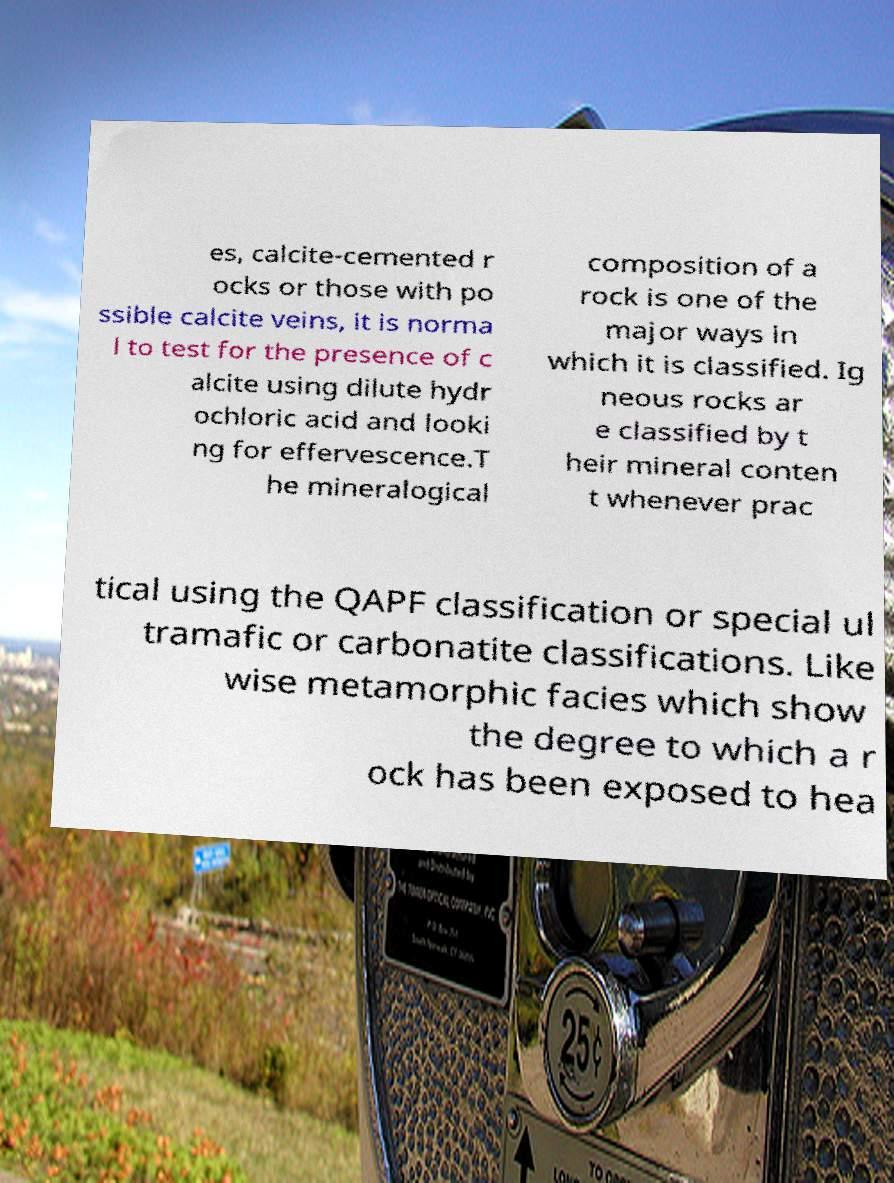What messages or text are displayed in this image? I need them in a readable, typed format. es, calcite-cemented r ocks or those with po ssible calcite veins, it is norma l to test for the presence of c alcite using dilute hydr ochloric acid and looki ng for effervescence.T he mineralogical composition of a rock is one of the major ways in which it is classified. Ig neous rocks ar e classified by t heir mineral conten t whenever prac tical using the QAPF classification or special ul tramafic or carbonatite classifications. Like wise metamorphic facies which show the degree to which a r ock has been exposed to hea 